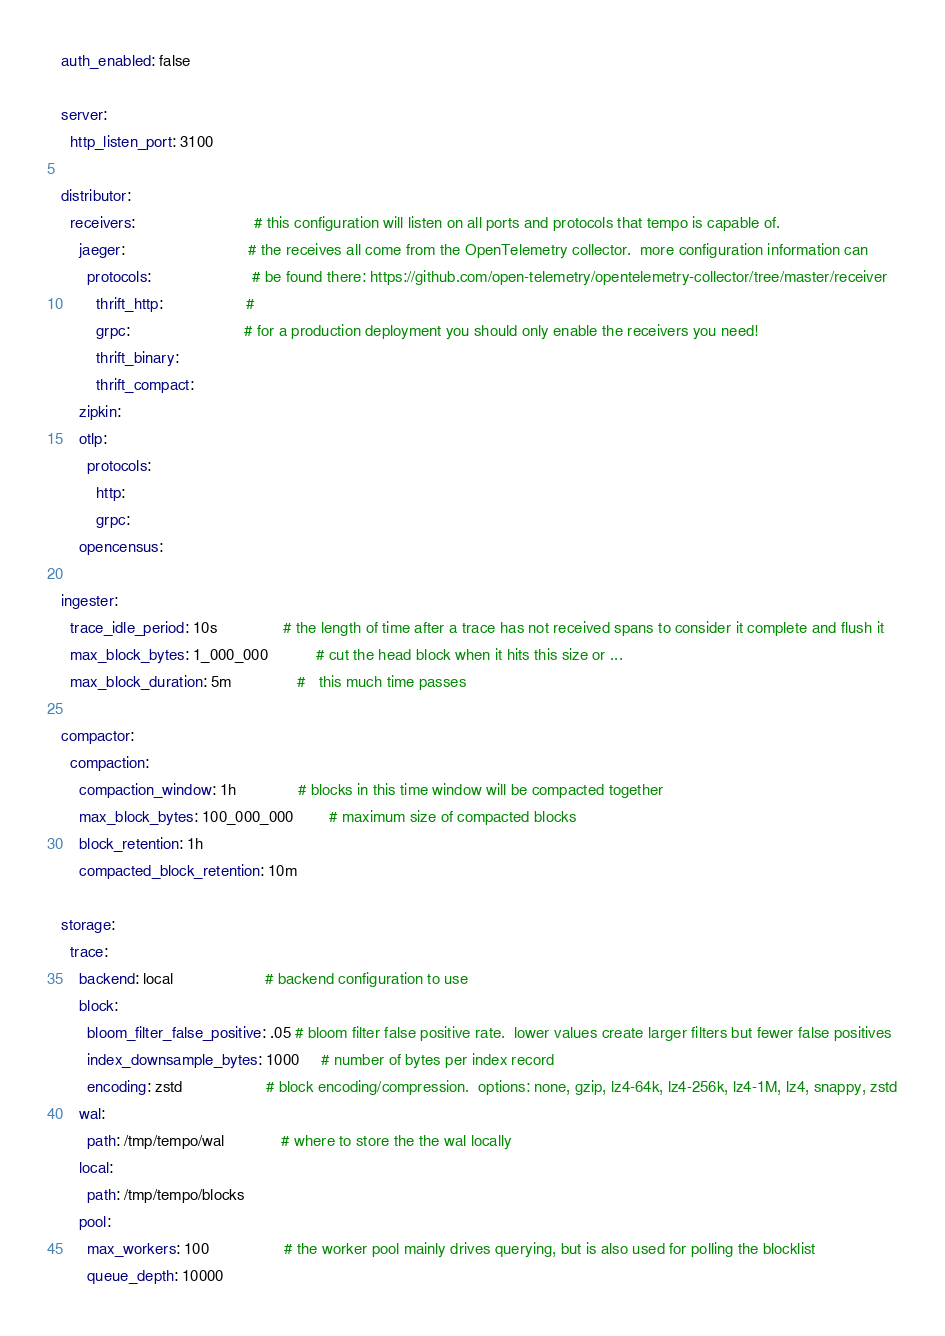<code> <loc_0><loc_0><loc_500><loc_500><_YAML_>auth_enabled: false

server:
  http_listen_port: 3100

distributor:
  receivers:                           # this configuration will listen on all ports and protocols that tempo is capable of.
    jaeger:                            # the receives all come from the OpenTelemetry collector.  more configuration information can
      protocols:                       # be found there: https://github.com/open-telemetry/opentelemetry-collector/tree/master/receiver
        thrift_http:                   #
        grpc:                          # for a production deployment you should only enable the receivers you need!
        thrift_binary:
        thrift_compact:
    zipkin:
    otlp:
      protocols:
        http:
        grpc:
    opencensus:

ingester:
  trace_idle_period: 10s               # the length of time after a trace has not received spans to consider it complete and flush it
  max_block_bytes: 1_000_000           # cut the head block when it hits this size or ...
  max_block_duration: 5m               #   this much time passes

compactor:
  compaction:
    compaction_window: 1h              # blocks in this time window will be compacted together
    max_block_bytes: 100_000_000        # maximum size of compacted blocks
    block_retention: 1h
    compacted_block_retention: 10m

storage:
  trace:
    backend: local                     # backend configuration to use
    block:
      bloom_filter_false_positive: .05 # bloom filter false positive rate.  lower values create larger filters but fewer false positives
      index_downsample_bytes: 1000     # number of bytes per index record
      encoding: zstd                   # block encoding/compression.  options: none, gzip, lz4-64k, lz4-256k, lz4-1M, lz4, snappy, zstd
    wal:
      path: /tmp/tempo/wal             # where to store the the wal locally
    local:
      path: /tmp/tempo/blocks
    pool:
      max_workers: 100                 # the worker pool mainly drives querying, but is also used for polling the blocklist
      queue_depth: 10000</code> 